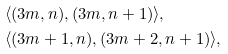<formula> <loc_0><loc_0><loc_500><loc_500>& \langle ( 3 m , n ) , ( 3 m , n + 1 ) \rangle , \\ & \langle ( 3 m + 1 , n ) , ( 3 m + 2 , n + 1 ) \rangle ,</formula> 